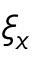Convert formula to latex. <formula><loc_0><loc_0><loc_500><loc_500>\xi _ { x }</formula> 